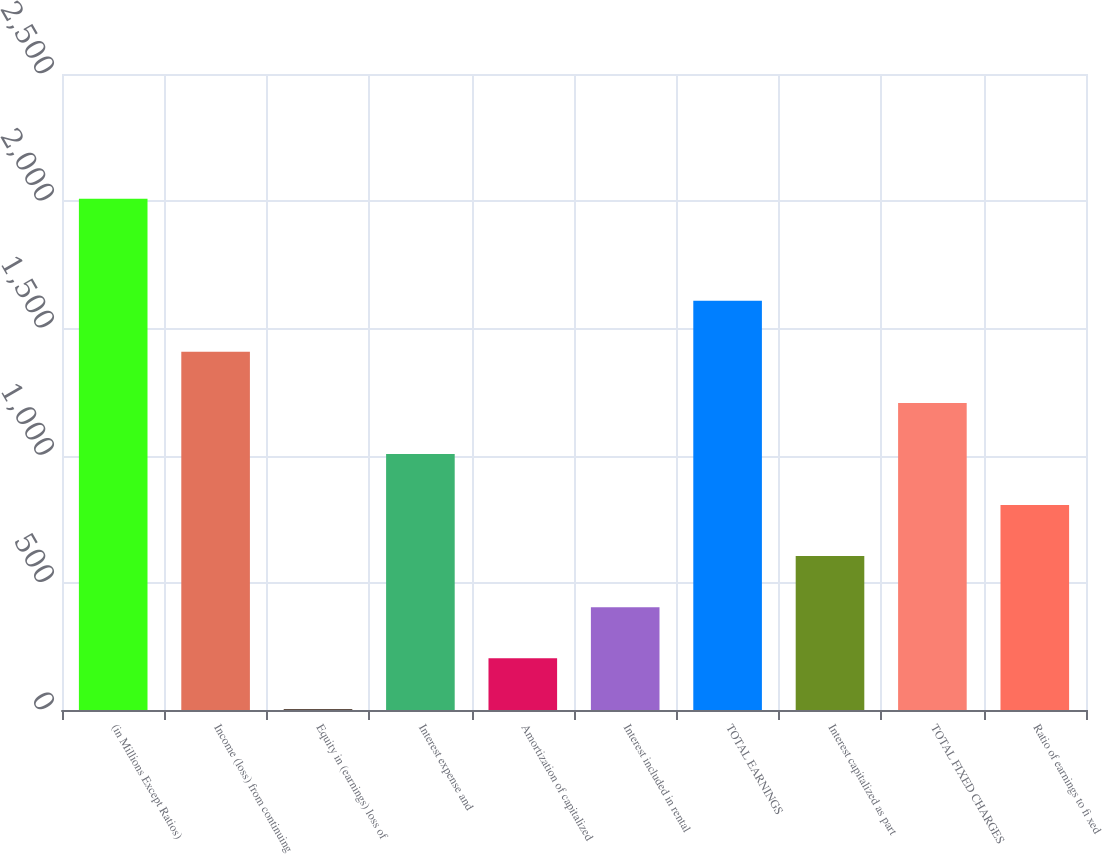Convert chart. <chart><loc_0><loc_0><loc_500><loc_500><bar_chart><fcel>(in Millions Except Ratios)<fcel>Income (loss) from continuing<fcel>Equity in (earnings) loss of<fcel>Interest expense and<fcel>Amortization of capitalized<fcel>Interest included in rental<fcel>TOTAL EARNINGS<fcel>Interest capitalized as part<fcel>TOTAL FIXED CHARGES<fcel>Ratio of earnings to fi xed<nl><fcel>2010<fcel>1407.81<fcel>2.7<fcel>1006.35<fcel>203.43<fcel>404.16<fcel>1608.54<fcel>604.89<fcel>1207.08<fcel>805.62<nl></chart> 